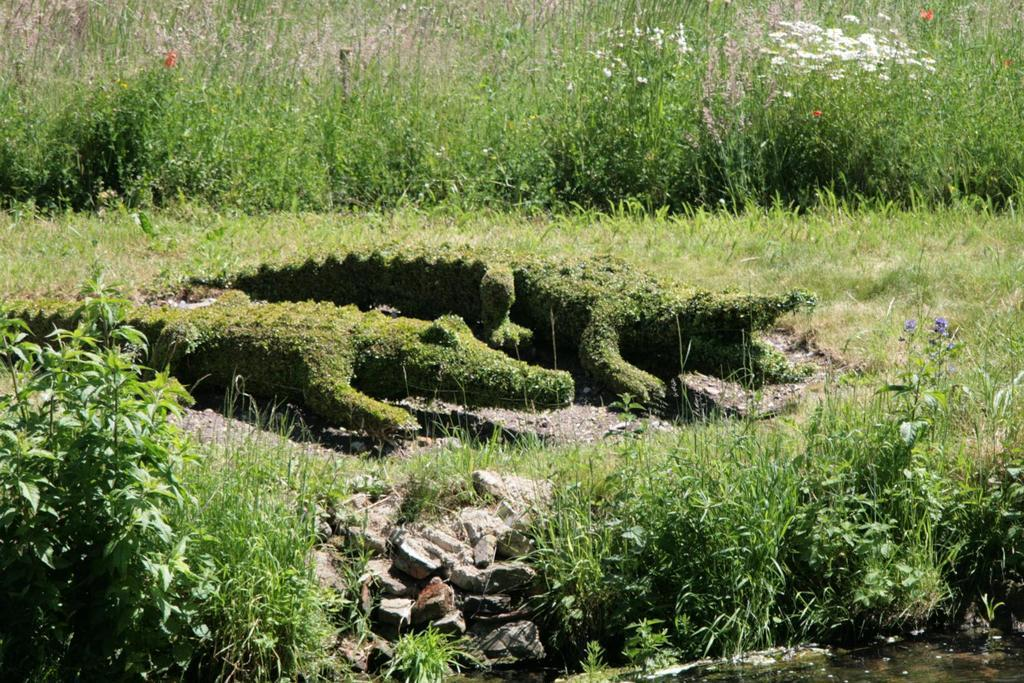What type of surface can be seen in the image? The ground is visible in the image. What is covering the ground? There is grass on the ground. What other types of vegetation are present in the image? There are plants and flowers in the image. Can you describe a specific plant in the image? Yes, there is a plant shaped like a crocodile in the image. How many birds are sitting on the crocodile-shaped plant in the image? There are no birds present in the image, so it is not possible to answer that question. 